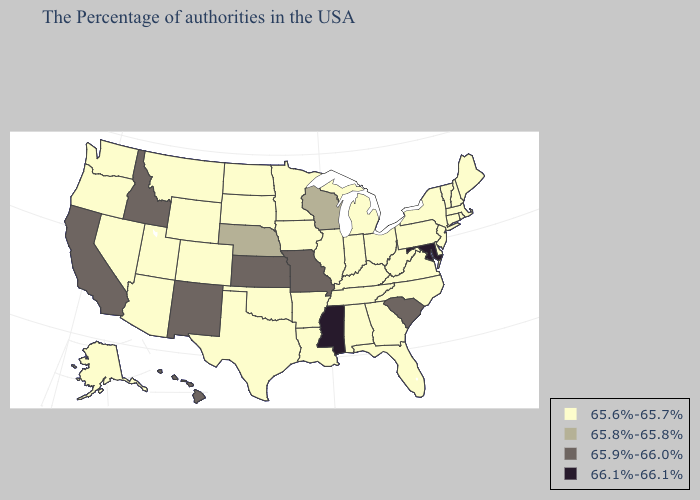Name the states that have a value in the range 66.1%-66.1%?
Give a very brief answer. Maryland, Mississippi. Name the states that have a value in the range 66.1%-66.1%?
Short answer required. Maryland, Mississippi. What is the lowest value in the USA?
Concise answer only. 65.6%-65.7%. Does Georgia have a higher value than Missouri?
Answer briefly. No. Name the states that have a value in the range 66.1%-66.1%?
Answer briefly. Maryland, Mississippi. Does Montana have the lowest value in the West?
Give a very brief answer. Yes. Name the states that have a value in the range 65.8%-65.8%?
Answer briefly. Wisconsin, Nebraska. Does Alaska have the same value as Illinois?
Short answer required. Yes. What is the value of Tennessee?
Write a very short answer. 65.6%-65.7%. Name the states that have a value in the range 65.8%-65.8%?
Be succinct. Wisconsin, Nebraska. Does Louisiana have the lowest value in the USA?
Concise answer only. Yes. Name the states that have a value in the range 66.1%-66.1%?
Give a very brief answer. Maryland, Mississippi. What is the value of South Dakota?
Short answer required. 65.6%-65.7%. What is the value of Vermont?
Short answer required. 65.6%-65.7%. Name the states that have a value in the range 65.6%-65.7%?
Quick response, please. Maine, Massachusetts, Rhode Island, New Hampshire, Vermont, Connecticut, New York, New Jersey, Delaware, Pennsylvania, Virginia, North Carolina, West Virginia, Ohio, Florida, Georgia, Michigan, Kentucky, Indiana, Alabama, Tennessee, Illinois, Louisiana, Arkansas, Minnesota, Iowa, Oklahoma, Texas, South Dakota, North Dakota, Wyoming, Colorado, Utah, Montana, Arizona, Nevada, Washington, Oregon, Alaska. 